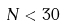Convert formula to latex. <formula><loc_0><loc_0><loc_500><loc_500>N < 3 0</formula> 